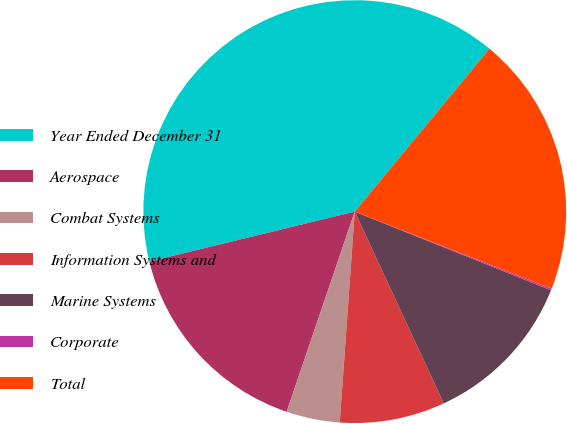<chart> <loc_0><loc_0><loc_500><loc_500><pie_chart><fcel>Year Ended December 31<fcel>Aerospace<fcel>Combat Systems<fcel>Information Systems and<fcel>Marine Systems<fcel>Corporate<fcel>Total<nl><fcel>39.79%<fcel>15.99%<fcel>4.09%<fcel>8.05%<fcel>12.02%<fcel>0.12%<fcel>19.95%<nl></chart> 